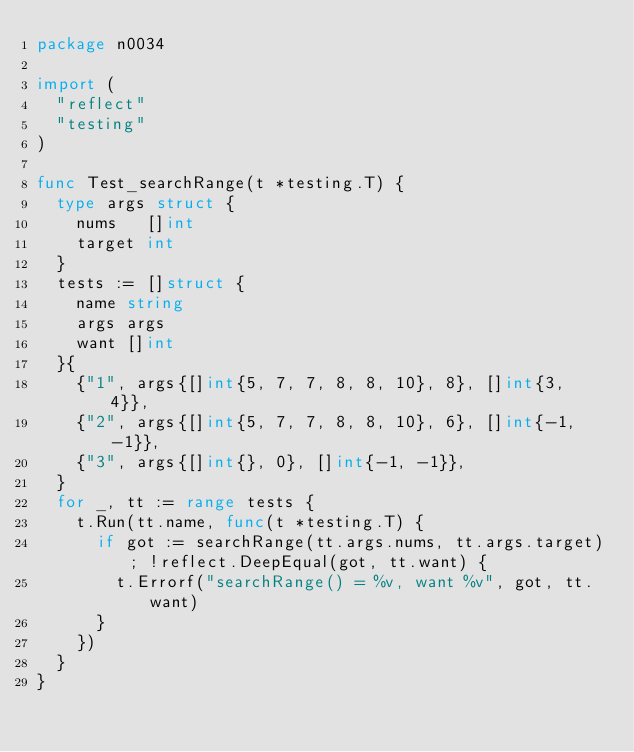<code> <loc_0><loc_0><loc_500><loc_500><_Go_>package n0034

import (
	"reflect"
	"testing"
)

func Test_searchRange(t *testing.T) {
	type args struct {
		nums   []int
		target int
	}
	tests := []struct {
		name string
		args args
		want []int
	}{
		{"1", args{[]int{5, 7, 7, 8, 8, 10}, 8}, []int{3, 4}},
		{"2", args{[]int{5, 7, 7, 8, 8, 10}, 6}, []int{-1, -1}},
		{"3", args{[]int{}, 0}, []int{-1, -1}},
	}
	for _, tt := range tests {
		t.Run(tt.name, func(t *testing.T) {
			if got := searchRange(tt.args.nums, tt.args.target); !reflect.DeepEqual(got, tt.want) {
				t.Errorf("searchRange() = %v, want %v", got, tt.want)
			}
		})
	}
}
</code> 